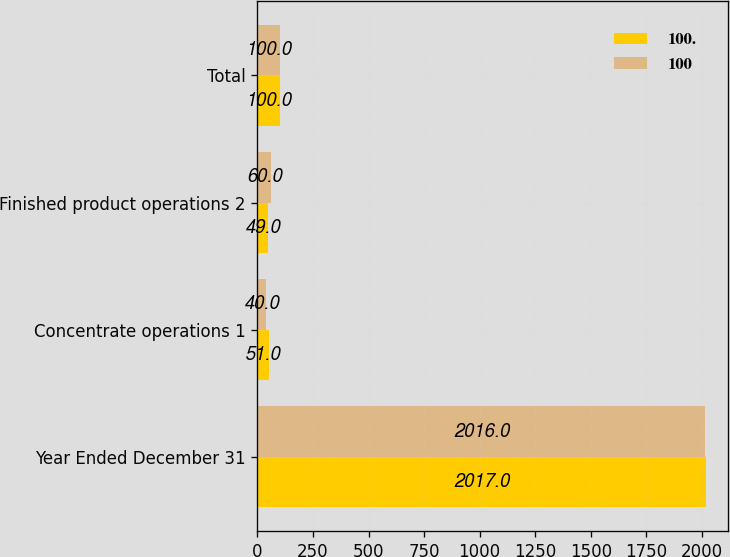<chart> <loc_0><loc_0><loc_500><loc_500><stacked_bar_chart><ecel><fcel>Year Ended December 31<fcel>Concentrate operations 1<fcel>Finished product operations 2<fcel>Total<nl><fcel>100<fcel>2017<fcel>51<fcel>49<fcel>100<nl><fcel>100<fcel>2016<fcel>40<fcel>60<fcel>100<nl></chart> 